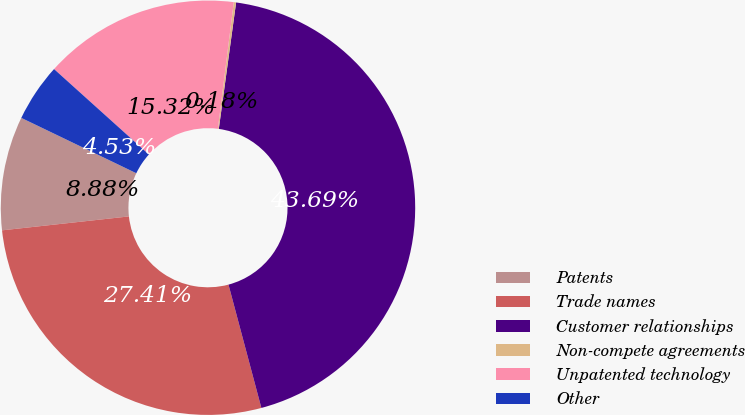Convert chart to OTSL. <chart><loc_0><loc_0><loc_500><loc_500><pie_chart><fcel>Patents<fcel>Trade names<fcel>Customer relationships<fcel>Non-compete agreements<fcel>Unpatented technology<fcel>Other<nl><fcel>8.88%<fcel>27.41%<fcel>43.69%<fcel>0.18%<fcel>15.32%<fcel>4.53%<nl></chart> 